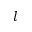<formula> <loc_0><loc_0><loc_500><loc_500>l</formula> 